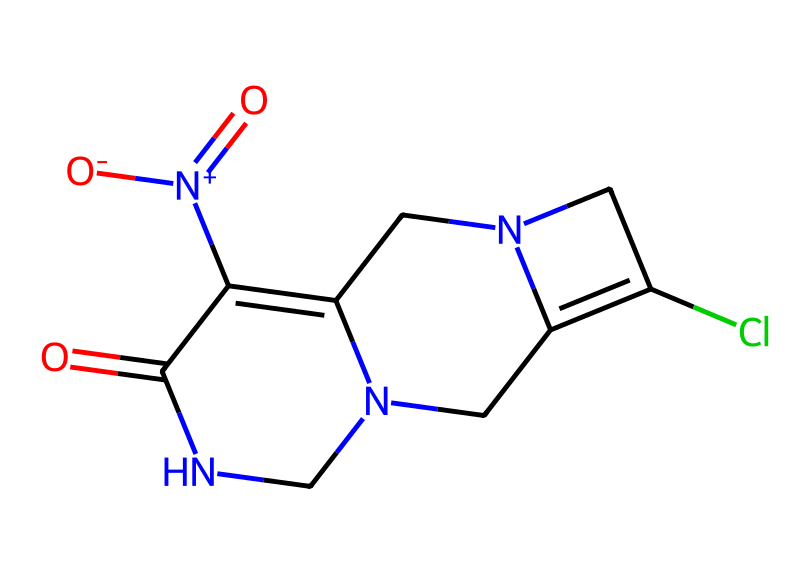What is the molecular formula of this neonicotinoid? To determine the molecular formula, count the number of each type of atom present in the SMILES notation. From the structure, you can see that there are 8 carbon atoms (C), 10 hydrogen atoms (H), 3 nitrogen atoms (N), 2 oxygen atoms (O), and 1 chlorine atom (Cl). Putting it all together, the molecular formula is C8H10ClN3O2.
Answer: C8H10ClN3O2 How many nitrogen atoms are present in this chemical? By analyzing the SMILES representation, you can spot the nitrogen atoms represented as 'N'. Counting them reveals that there are three nitrogen atoms in total.
Answer: 3 What type of chemical class does this substance belong to? Based on its structure and the presence of a nitro group, as well as its role as an insecticide, this substance is classified as a neonicotinoid.
Answer: neonicotinoid What functional groups are present in this neonicotinoid? Look for specific groups attached to the main carbon skeleton. The SMILES indicates the presence of both a nitro group (-NO2) and a cyclic amine structure due to the nitrogen atoms, making these the functional groups identified in the molecule.
Answer: nitro and cyclic amine What effect do neonicotinoids have on insect nervous systems? Understanding how neonicotinoids act involves recognizing that they are agonists of nicotinic acetylcholine receptors, which disrupt normal neuromuscular transmission leading to paralysis in insects.
Answer: paralysis How many rings are present in this chemical structure? The structure contains multiple nitrogen atoms that are part of cyclic formations. By visually or structurally assessing the connections, you can identify there are two rings in total.
Answer: 2 